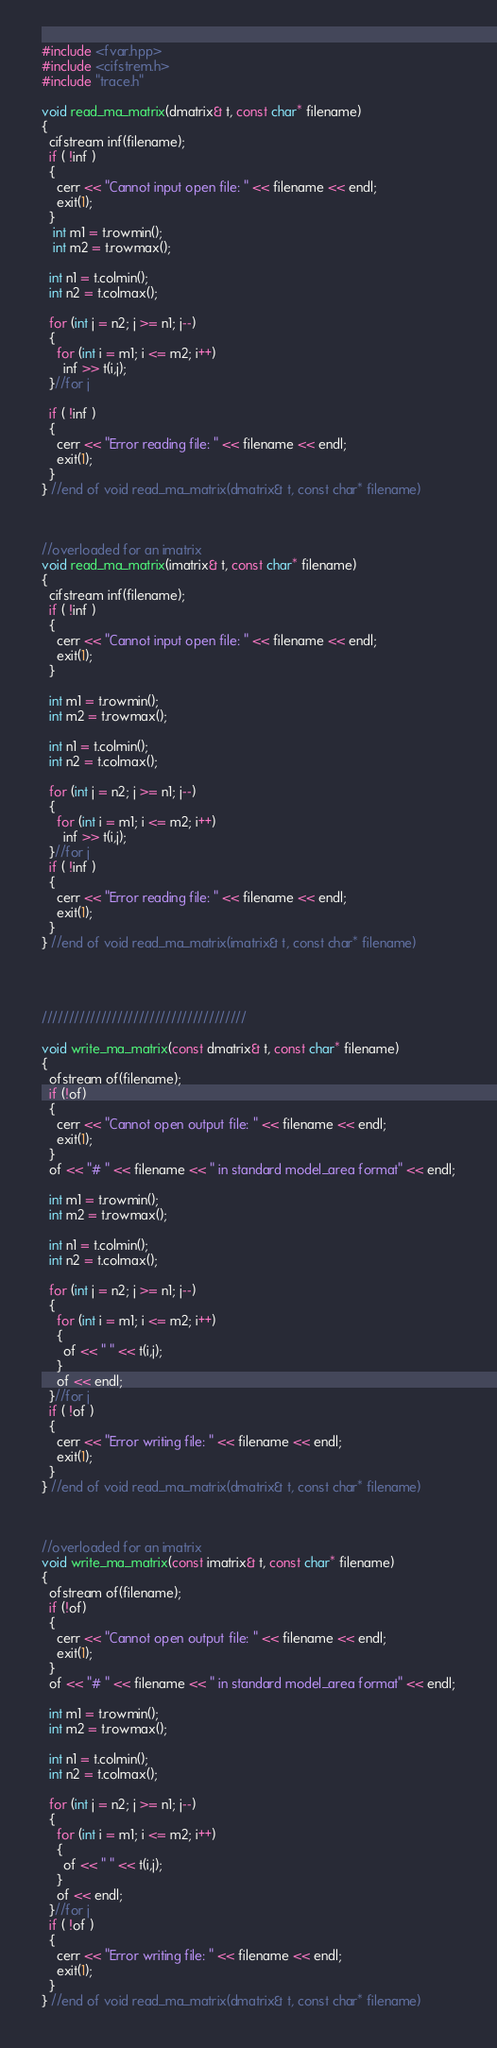<code> <loc_0><loc_0><loc_500><loc_500><_C++_>#include <fvar.hpp>
#include <cifstrem.h>
#include "trace.h"

void read_ma_matrix(dmatrix& t, const char* filename)
{
  cifstream inf(filename);
  if ( !inf )
  {
    cerr << "Cannot input open file: " << filename << endl;
    exit(1);
  } 
   int m1 = t.rowmin();
   int m2 = t.rowmax(); 
 
  int n1 = t.colmin();
  int n2 = t.colmax();
  
  for (int j = n2; j >= n1; j--)
  {
    for (int i = m1; i <= m2; i++)
      inf >> t(i,j);
  }//for j
  
  if ( !inf )
  {
    cerr << "Error reading file: " << filename << endl;
    exit(1);
  }
} //end of void read_ma_matrix(dmatrix& t, const char* filename)



//overloaded for an imatrix
void read_ma_matrix(imatrix& t, const char* filename)
{
  cifstream inf(filename);
  if ( !inf )
  {
    cerr << "Cannot input open file: " << filename << endl;
    exit(1);
  }

  int m1 = t.rowmin();
  int m2 = t.rowmax(); 
 
  int n1 = t.colmin();
  int n2 = t.colmax();

  for (int j = n2; j >= n1; j--)
  {
    for (int i = m1; i <= m2; i++)
      inf >> t(i,j);
  }//for j
  if ( !inf )
  {
    cerr << "Error reading file: " << filename << endl;
    exit(1);
  }
} //end of void read_ma_matrix(imatrix& t, const char* filename)




//////////////////////////////////////

void write_ma_matrix(const dmatrix& t, const char* filename)
{
  ofstream of(filename);
  if (!of)
  {
    cerr << "Cannot open output file: " << filename << endl;
    exit(1);
  }
  of << "# " << filename << " in standard model_area format" << endl;

  int m1 = t.rowmin();
  int m2 = t.rowmax(); 
 
  int n1 = t.colmin();
  int n2 = t.colmax();
  
  for (int j = n2; j >= n1; j--)
  {
    for (int i = m1; i <= m2; i++)
    {
      of << " " << t(i,j);
    }
    of << endl;
  }//for j
  if ( !of )
  {
    cerr << "Error writing file: " << filename << endl;
    exit(1);
  }
} //end of void read_ma_matrix(dmatrix& t, const char* filename)



//overloaded for an imatrix
void write_ma_matrix(const imatrix& t, const char* filename)
{
  ofstream of(filename);
  if (!of)
  {
    cerr << "Cannot open output file: " << filename << endl;
    exit(1);
  }
  of << "# " << filename << " in standard model_area format" << endl;
  
  int m1 = t.rowmin();
  int m2 = t.rowmax(); 
 
  int n1 = t.colmin();
  int n2 = t.colmax();
  
  for (int j = n2; j >= n1; j--)
  {
    for (int i = m1; i <= m2; i++)
    {
      of << " " << t(i,j);
    }
    of << endl;
  }//for j
  if ( !of )
  {
    cerr << "Error writing file: " << filename << endl;
    exit(1);
  }
} //end of void read_ma_matrix(dmatrix& t, const char* filename)
</code> 